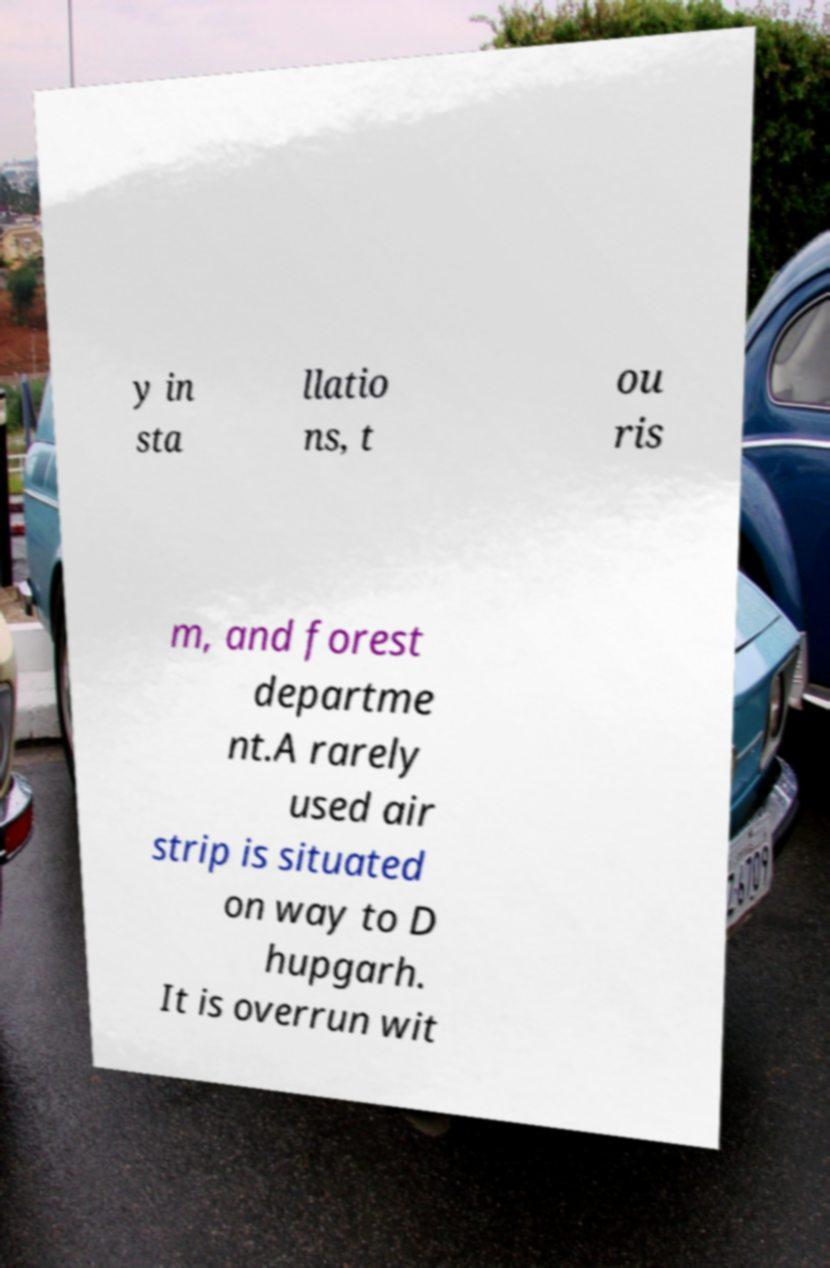Can you read and provide the text displayed in the image?This photo seems to have some interesting text. Can you extract and type it out for me? y in sta llatio ns, t ou ris m, and forest departme nt.A rarely used air strip is situated on way to D hupgarh. It is overrun wit 